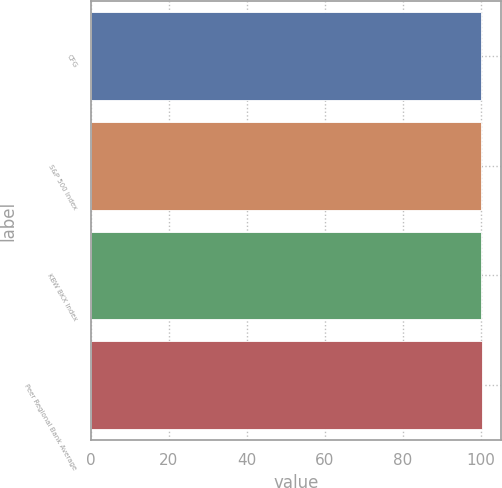Convert chart to OTSL. <chart><loc_0><loc_0><loc_500><loc_500><bar_chart><fcel>CFG<fcel>S&P 500 Index<fcel>KBW BKX Index<fcel>Peer Regional Bank Average<nl><fcel>100<fcel>100.1<fcel>100.2<fcel>100.3<nl></chart> 